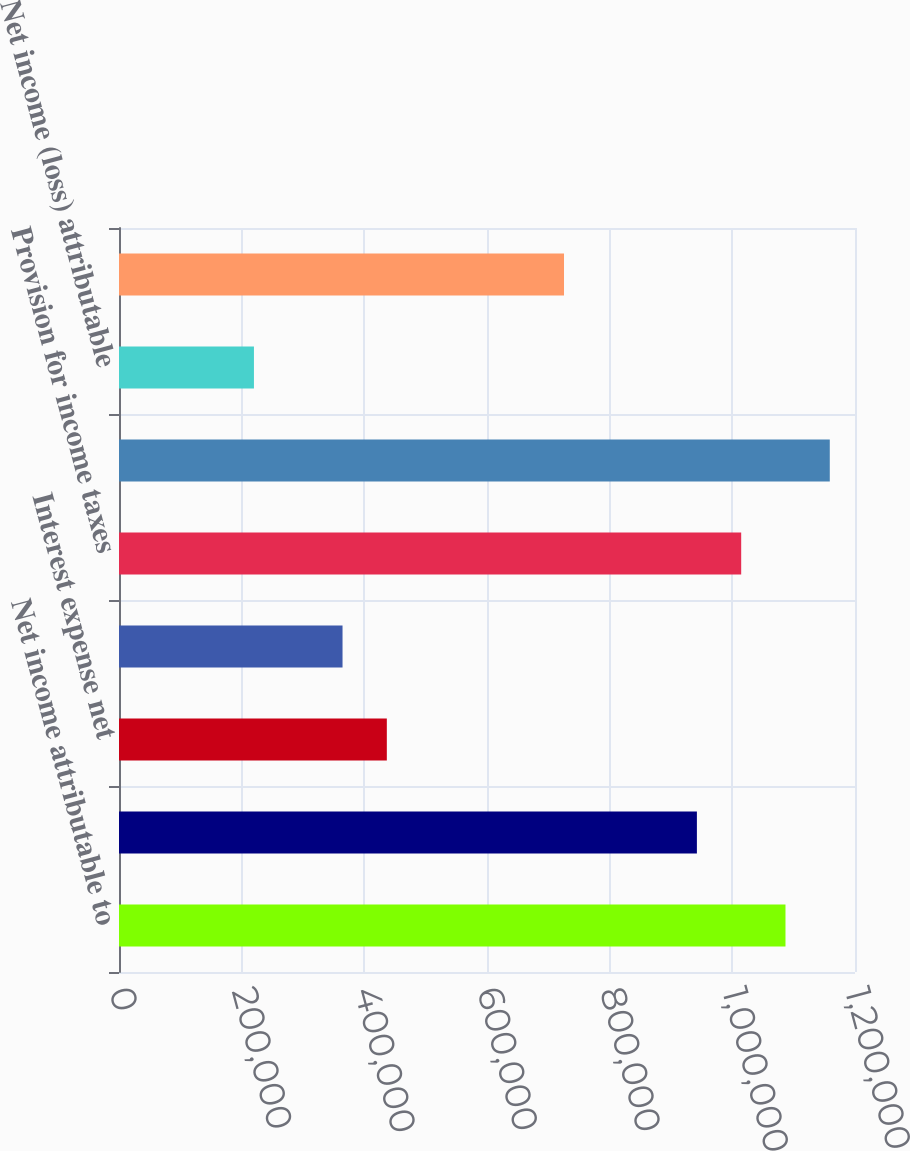Convert chart to OTSL. <chart><loc_0><loc_0><loc_500><loc_500><bar_chart><fcel>Net income attributable to<fcel>Depreciation and amortization<fcel>Interest expense net<fcel>Royalty and management service<fcel>Provision for income taxes<fcel>EBITDA<fcel>Net income (loss) attributable<fcel>Interest expense (income) net<nl><fcel>1.08666e+06<fcel>942221<fcel>436677<fcel>364456<fcel>1.01444e+06<fcel>1.15888e+06<fcel>220015<fcel>725559<nl></chart> 